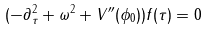Convert formula to latex. <formula><loc_0><loc_0><loc_500><loc_500>( - \partial _ { \tau } ^ { 2 } + \omega ^ { 2 } + V ^ { \prime \prime } ( \phi _ { 0 } ) ) f ( \tau ) = 0</formula> 